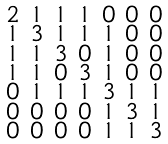<formula> <loc_0><loc_0><loc_500><loc_500>\begin{smallmatrix} 2 & 1 & 1 & 1 & 0 & 0 & 0 \\ 1 & 3 & 1 & 1 & 1 & 0 & 0 \\ 1 & 1 & 3 & 0 & 1 & 0 & 0 \\ 1 & 1 & 0 & 3 & 1 & 0 & 0 \\ 0 & 1 & 1 & 1 & 3 & 1 & 1 \\ 0 & 0 & 0 & 0 & 1 & 3 & 1 \\ 0 & 0 & 0 & 0 & 1 & 1 & 3 \end{smallmatrix}</formula> 